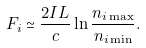Convert formula to latex. <formula><loc_0><loc_0><loc_500><loc_500>F _ { i } \simeq \frac { 2 I L } { c } \ln \frac { n _ { i \max } } { n _ { i \min } } .</formula> 